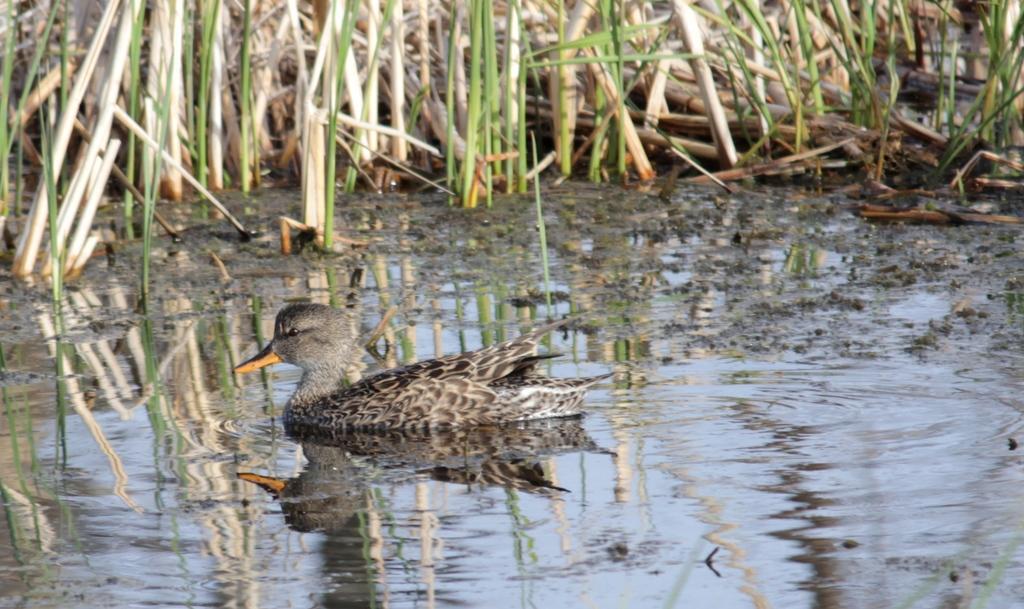How would you summarize this image in a sentence or two? In the center of the image we can see a duck on the water. In the background there is grass. 